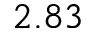<formula> <loc_0><loc_0><loc_500><loc_500>2 . 8 3</formula> 